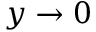<formula> <loc_0><loc_0><loc_500><loc_500>y \to 0</formula> 